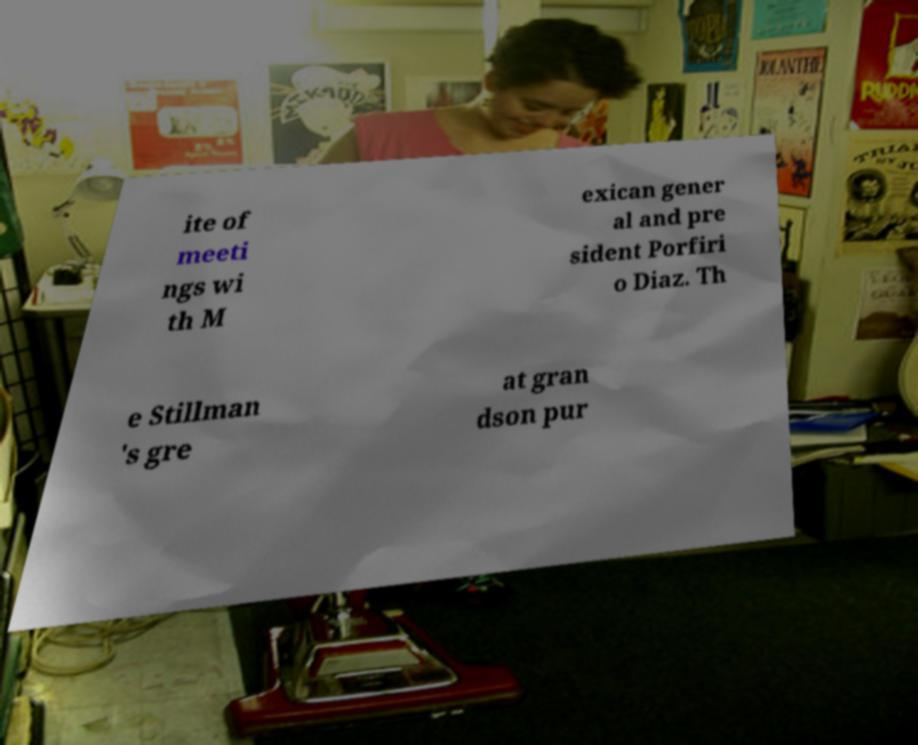Can you read and provide the text displayed in the image?This photo seems to have some interesting text. Can you extract and type it out for me? ite of meeti ngs wi th M exican gener al and pre sident Porfiri o Diaz. Th e Stillman 's gre at gran dson pur 